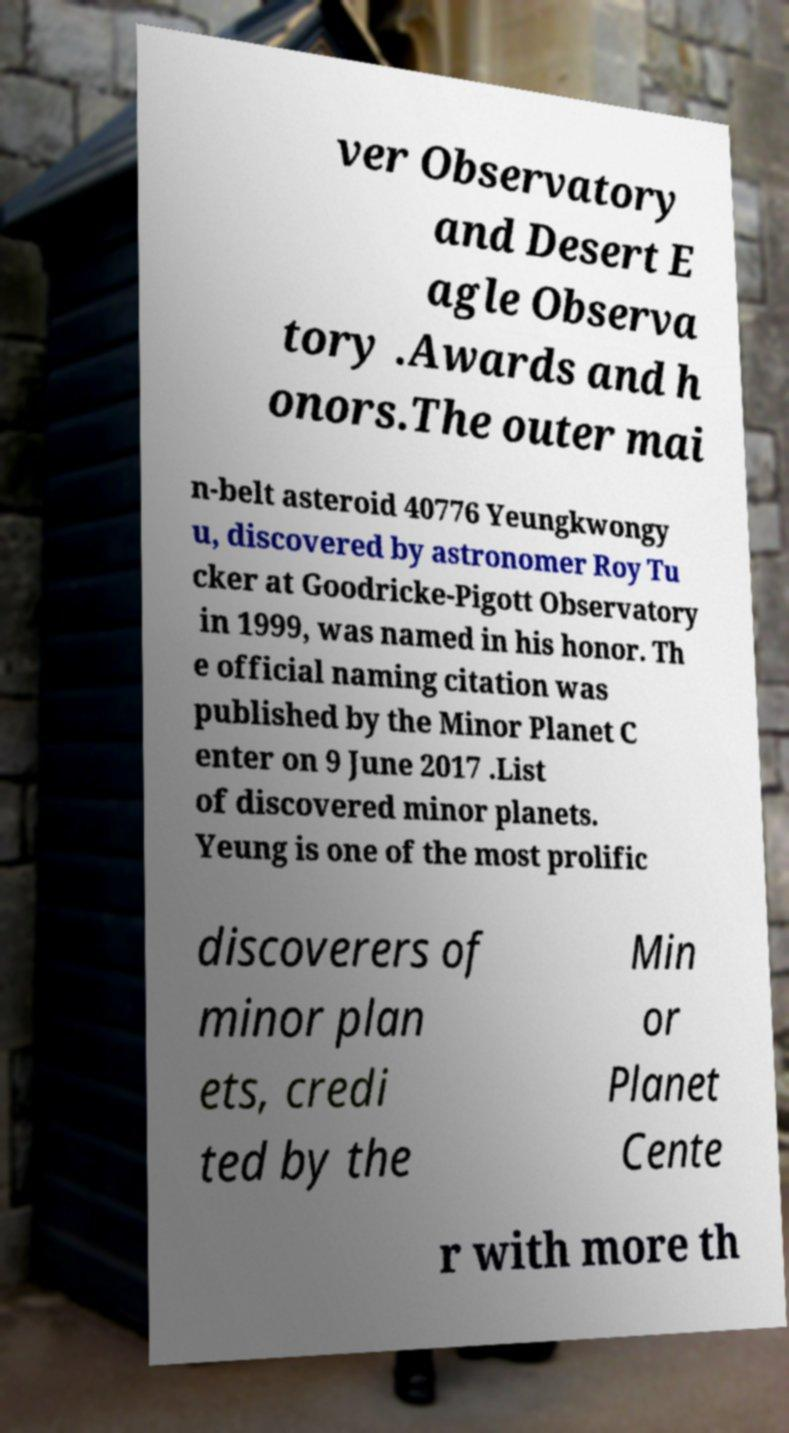Could you extract and type out the text from this image? ver Observatory and Desert E agle Observa tory .Awards and h onors.The outer mai n-belt asteroid 40776 Yeungkwongy u, discovered by astronomer Roy Tu cker at Goodricke-Pigott Observatory in 1999, was named in his honor. Th e official naming citation was published by the Minor Planet C enter on 9 June 2017 .List of discovered minor planets. Yeung is one of the most prolific discoverers of minor plan ets, credi ted by the Min or Planet Cente r with more th 